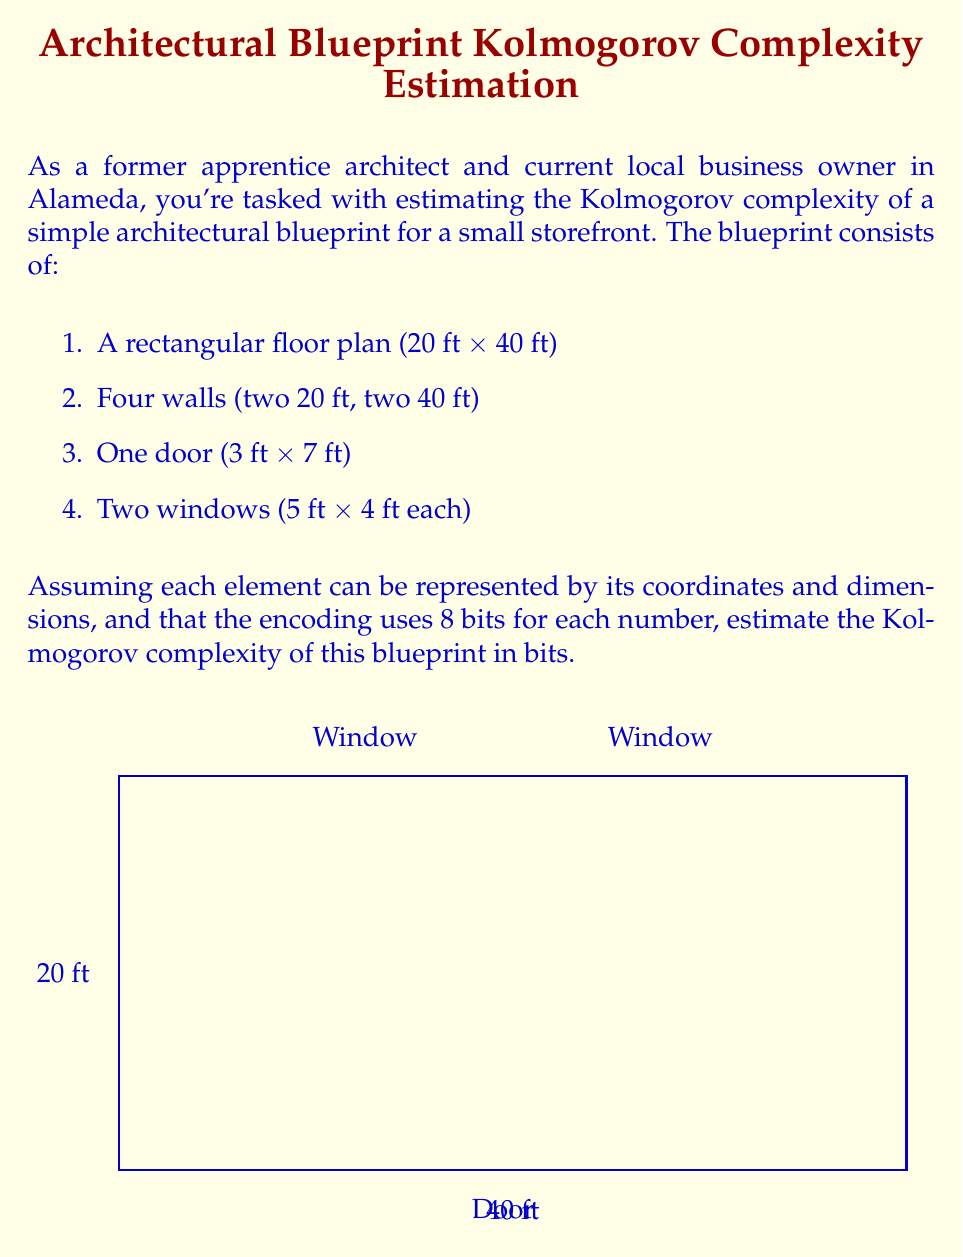Teach me how to tackle this problem. Let's break down the problem step-by-step:

1) First, we need to count the number of elements and their required information:

   - Floor plan: 4 coordinates (x1, y1, x2, y2)
   - Walls: Already defined by floor plan, no additional information needed
   - Door: 2 coordinates (x, y) and 2 dimensions (width, height)
   - Windows: 2 sets of 2 coordinates (x, y) and 2 dimensions (width, height) each

2) Count the total number of numbers we need to encode:
   
   $4 + (2 + 2) + 2(2 + 2) = 16$ numbers

3) Each number is encoded using 8 bits:

   $16 * 8 = 128$ bits

4) We also need to consider the structure of the blueprint itself. We can estimate this as a small constant, let's say 32 bits to encode the type and number of elements.

5) The total Kolmogorov complexity estimate is thus:

   $128 + 32 = 160$ bits

This is a lower bound estimate, as the actual Kolmogorov complexity could be higher depending on the specific encoding scheme used and any additional details in the blueprint.
Answer: Approximately 160 bits 